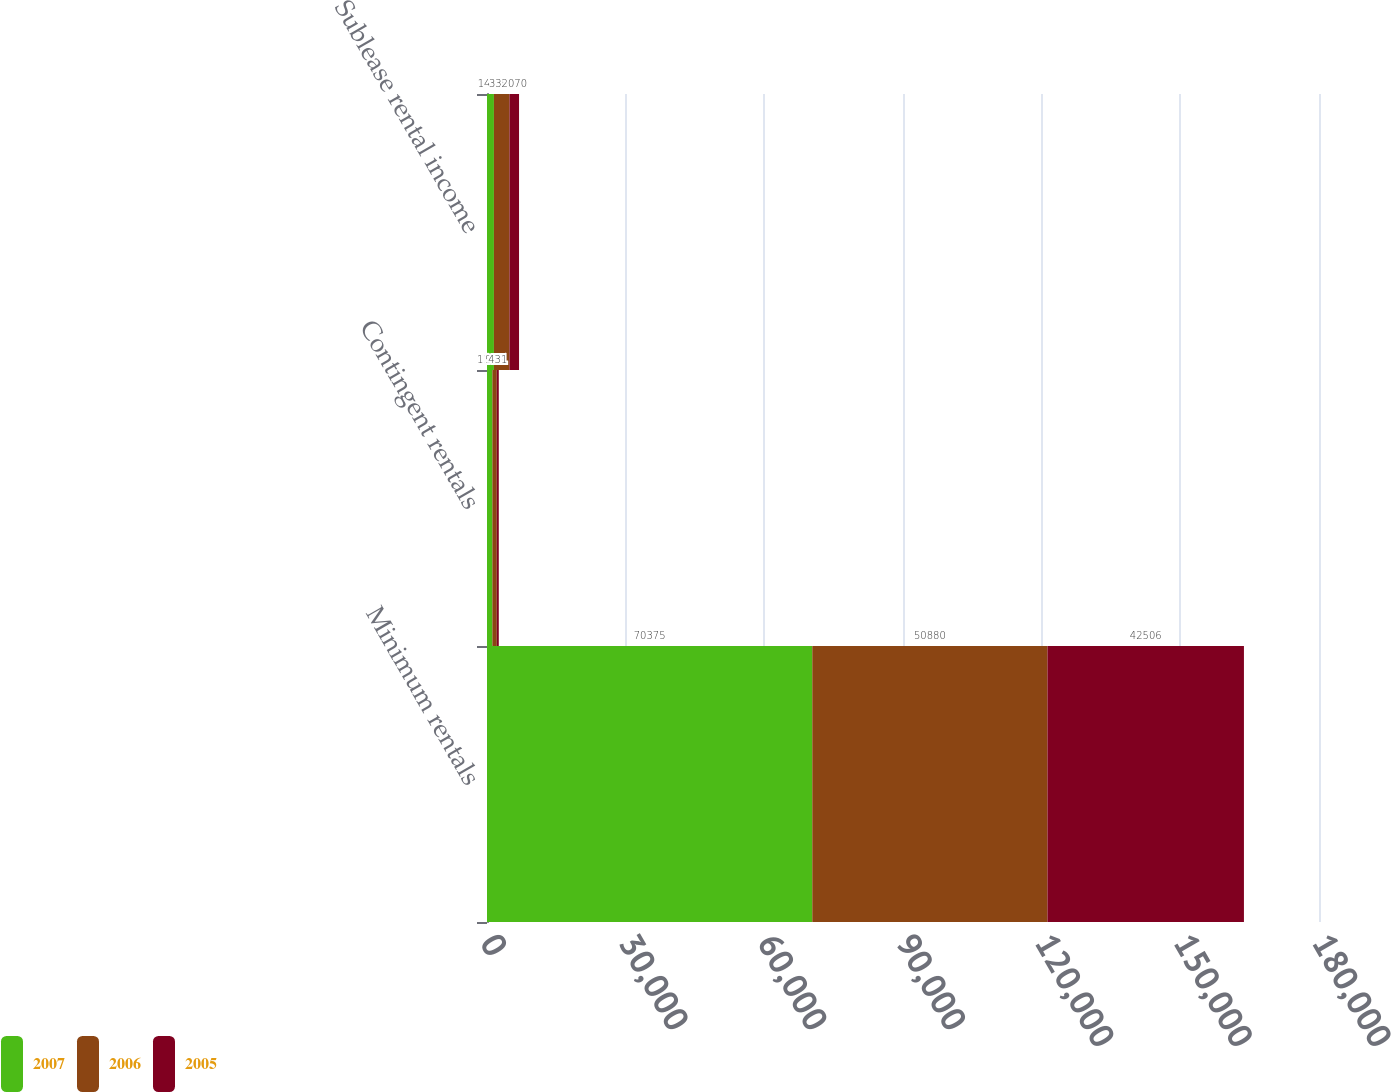Convert chart. <chart><loc_0><loc_0><loc_500><loc_500><stacked_bar_chart><ecel><fcel>Minimum rentals<fcel>Contingent rentals<fcel>Sublease rental income<nl><fcel>2007<fcel>70375<fcel>1162<fcel>1499<nl><fcel>2006<fcel>50880<fcel>955<fcel>3365<nl><fcel>2005<fcel>42506<fcel>431<fcel>2070<nl></chart> 